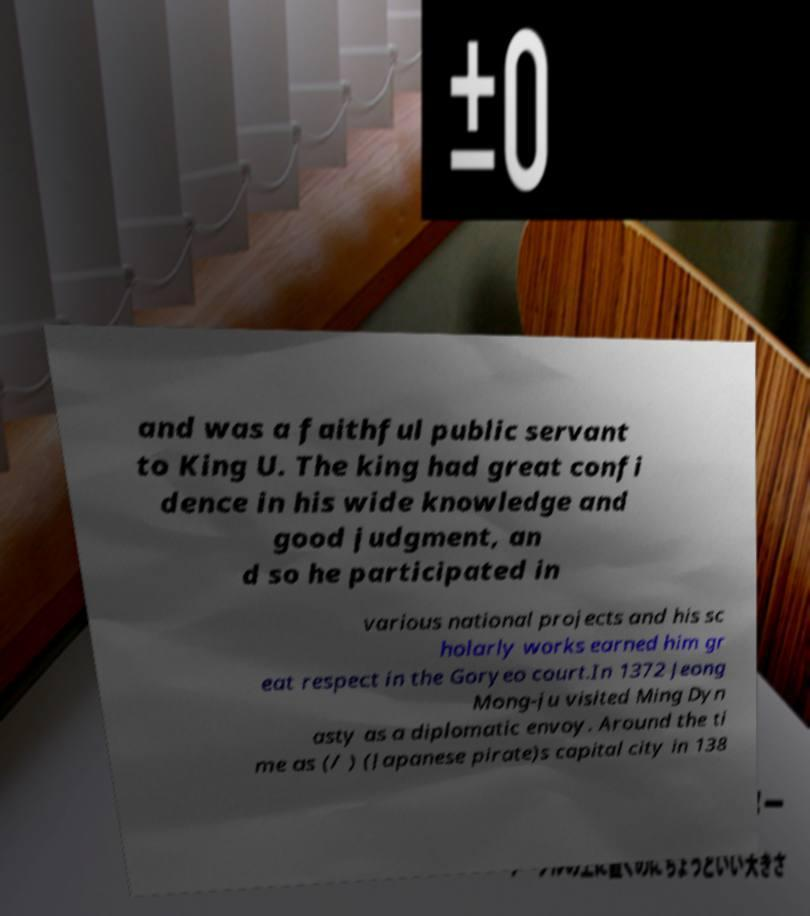Could you assist in decoding the text presented in this image and type it out clearly? and was a faithful public servant to King U. The king had great confi dence in his wide knowledge and good judgment, an d so he participated in various national projects and his sc holarly works earned him gr eat respect in the Goryeo court.In 1372 Jeong Mong-ju visited Ming Dyn asty as a diplomatic envoy. Around the ti me as (/ ) (Japanese pirate)s capital city in 138 